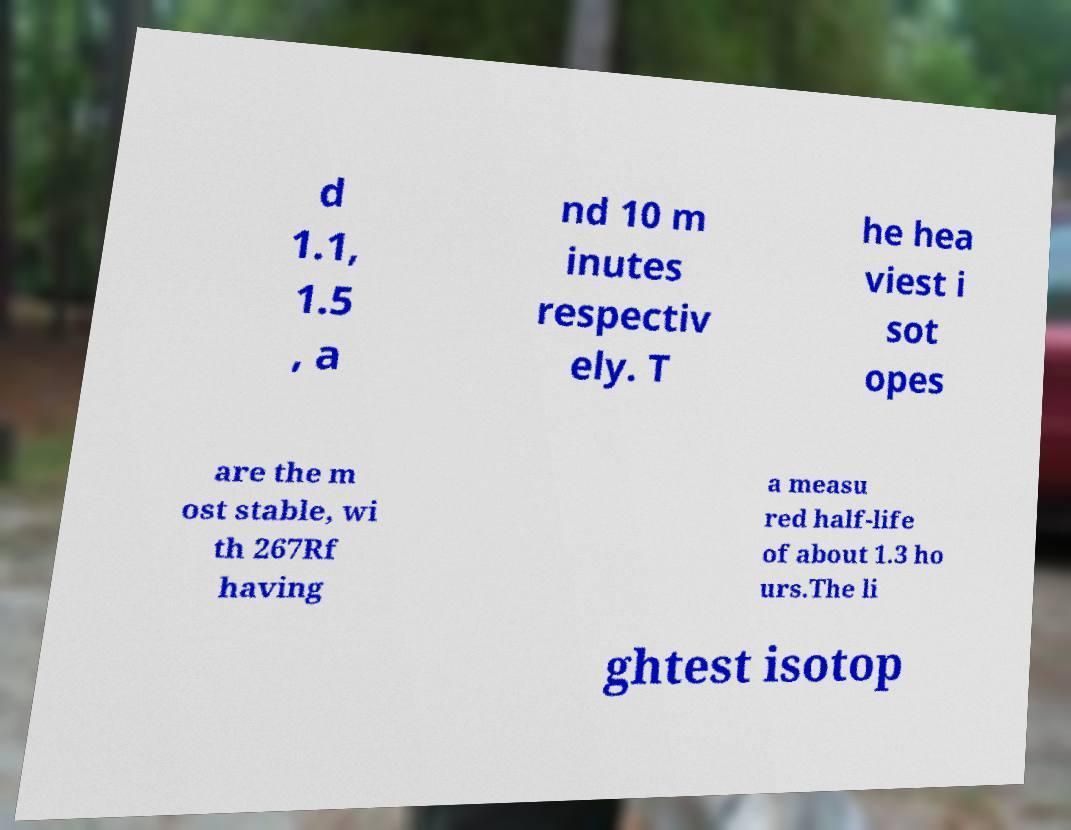Can you accurately transcribe the text from the provided image for me? d 1.1, 1.5 , a nd 10 m inutes respectiv ely. T he hea viest i sot opes are the m ost stable, wi th 267Rf having a measu red half-life of about 1.3 ho urs.The li ghtest isotop 